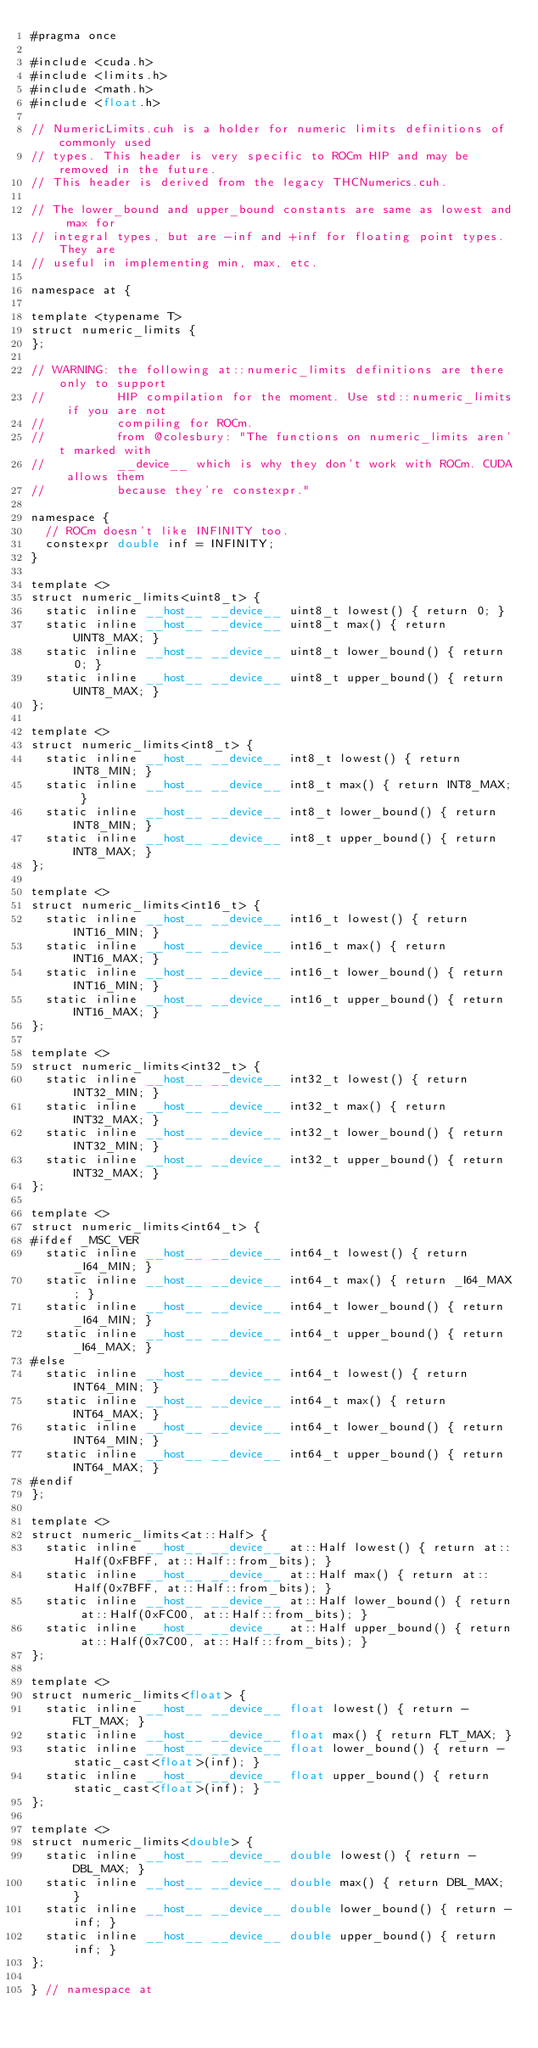Convert code to text. <code><loc_0><loc_0><loc_500><loc_500><_Cuda_>#pragma once

#include <cuda.h>
#include <limits.h>
#include <math.h>
#include <float.h>

// NumericLimits.cuh is a holder for numeric limits definitions of commonly used
// types. This header is very specific to ROCm HIP and may be removed in the future.
// This header is derived from the legacy THCNumerics.cuh.

// The lower_bound and upper_bound constants are same as lowest and max for
// integral types, but are -inf and +inf for floating point types. They are
// useful in implementing min, max, etc.

namespace at {

template <typename T>
struct numeric_limits {
};

// WARNING: the following at::numeric_limits definitions are there only to support
//          HIP compilation for the moment. Use std::numeric_limits if you are not
//          compiling for ROCm.
//          from @colesbury: "The functions on numeric_limits aren't marked with
//          __device__ which is why they don't work with ROCm. CUDA allows them
//          because they're constexpr."

namespace {
  // ROCm doesn't like INFINITY too.
  constexpr double inf = INFINITY;
}

template <>
struct numeric_limits<uint8_t> {
  static inline __host__ __device__ uint8_t lowest() { return 0; }
  static inline __host__ __device__ uint8_t max() { return UINT8_MAX; }
  static inline __host__ __device__ uint8_t lower_bound() { return 0; }
  static inline __host__ __device__ uint8_t upper_bound() { return UINT8_MAX; }
};

template <>
struct numeric_limits<int8_t> {
  static inline __host__ __device__ int8_t lowest() { return INT8_MIN; }
  static inline __host__ __device__ int8_t max() { return INT8_MAX; }
  static inline __host__ __device__ int8_t lower_bound() { return INT8_MIN; }
  static inline __host__ __device__ int8_t upper_bound() { return INT8_MAX; }
};

template <>
struct numeric_limits<int16_t> {
  static inline __host__ __device__ int16_t lowest() { return INT16_MIN; }
  static inline __host__ __device__ int16_t max() { return INT16_MAX; }
  static inline __host__ __device__ int16_t lower_bound() { return INT16_MIN; }
  static inline __host__ __device__ int16_t upper_bound() { return INT16_MAX; }
};

template <>
struct numeric_limits<int32_t> {
  static inline __host__ __device__ int32_t lowest() { return INT32_MIN; }
  static inline __host__ __device__ int32_t max() { return INT32_MAX; }
  static inline __host__ __device__ int32_t lower_bound() { return INT32_MIN; }
  static inline __host__ __device__ int32_t upper_bound() { return INT32_MAX; }
};

template <>
struct numeric_limits<int64_t> {
#ifdef _MSC_VER
  static inline __host__ __device__ int64_t lowest() { return _I64_MIN; }
  static inline __host__ __device__ int64_t max() { return _I64_MAX; }
  static inline __host__ __device__ int64_t lower_bound() { return _I64_MIN; }
  static inline __host__ __device__ int64_t upper_bound() { return _I64_MAX; }
#else
  static inline __host__ __device__ int64_t lowest() { return INT64_MIN; }
  static inline __host__ __device__ int64_t max() { return INT64_MAX; }
  static inline __host__ __device__ int64_t lower_bound() { return INT64_MIN; }
  static inline __host__ __device__ int64_t upper_bound() { return INT64_MAX; }
#endif
};

template <>
struct numeric_limits<at::Half> {
  static inline __host__ __device__ at::Half lowest() { return at::Half(0xFBFF, at::Half::from_bits); }
  static inline __host__ __device__ at::Half max() { return at::Half(0x7BFF, at::Half::from_bits); }
  static inline __host__ __device__ at::Half lower_bound() { return at::Half(0xFC00, at::Half::from_bits); }
  static inline __host__ __device__ at::Half upper_bound() { return at::Half(0x7C00, at::Half::from_bits); }
};

template <>
struct numeric_limits<float> {
  static inline __host__ __device__ float lowest() { return -FLT_MAX; }
  static inline __host__ __device__ float max() { return FLT_MAX; }
  static inline __host__ __device__ float lower_bound() { return -static_cast<float>(inf); }
  static inline __host__ __device__ float upper_bound() { return static_cast<float>(inf); }
};

template <>
struct numeric_limits<double> {
  static inline __host__ __device__ double lowest() { return -DBL_MAX; }
  static inline __host__ __device__ double max() { return DBL_MAX; }
  static inline __host__ __device__ double lower_bound() { return -inf; }
  static inline __host__ __device__ double upper_bound() { return inf; }
};

} // namespace at
</code> 